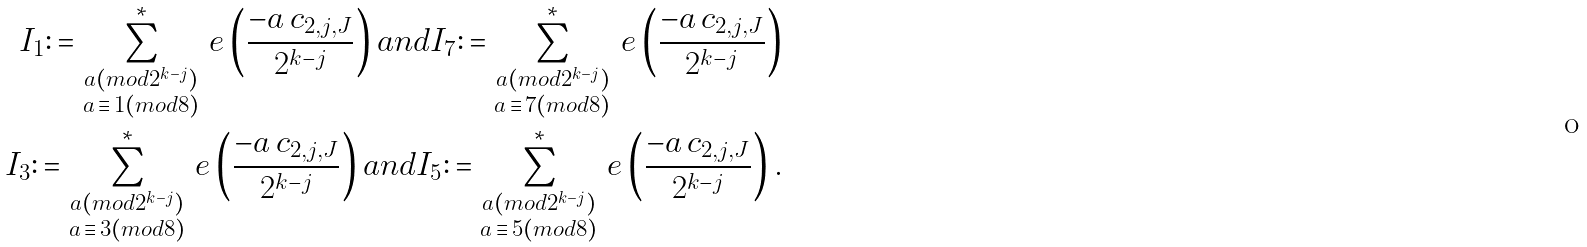<formula> <loc_0><loc_0><loc_500><loc_500>I _ { 1 } \colon = \sum _ { \substack { a ( m o d 2 ^ { k - j } ) \\ a \, \equiv \, 1 ( m o d 8 ) } } ^ { * } \, e \left ( \frac { - a \, c _ { 2 , j , J } } { 2 ^ { k - j } } \right ) a n d I _ { 7 } \colon = \sum _ { \substack { a ( m o d 2 ^ { k - j } ) \\ a \, \equiv \, 7 ( m o d 8 ) } } ^ { * } \, e \left ( \frac { - a \, c _ { 2 , j , J } } { 2 ^ { k - j } } \right ) \\ I _ { 3 } \colon = \sum _ { \substack { a ( m o d 2 ^ { k - j } ) \\ a \, \equiv \, 3 ( m o d 8 ) } } ^ { * } \, e \left ( \frac { - a \, c _ { 2 , j , J } } { 2 ^ { k - j } } \right ) a n d I _ { 5 } \colon = \sum _ { \substack { a ( m o d 2 ^ { k - j } ) \\ a \, \equiv \, 5 ( m o d 8 ) } } ^ { * } \, e \left ( \frac { - a \, c _ { 2 , j , J } } { 2 ^ { k - j } } \right ) .</formula> 